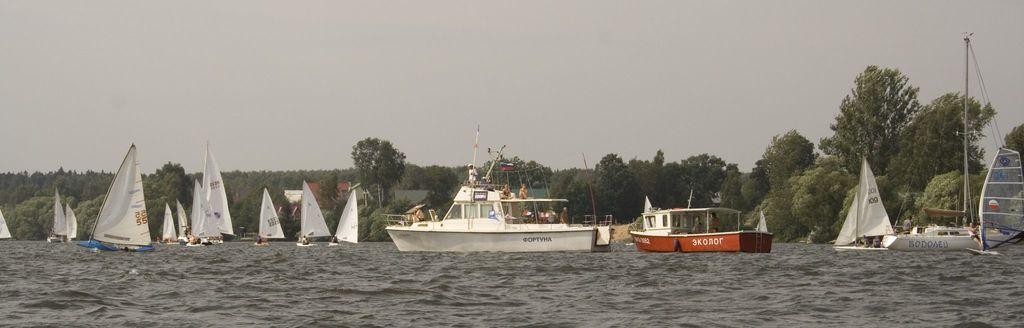Could you give a brief overview of what you see in this image? In this image I can see many boats are on the water. I can see few people are in the boats. In the background I can see many trees and the sky. 